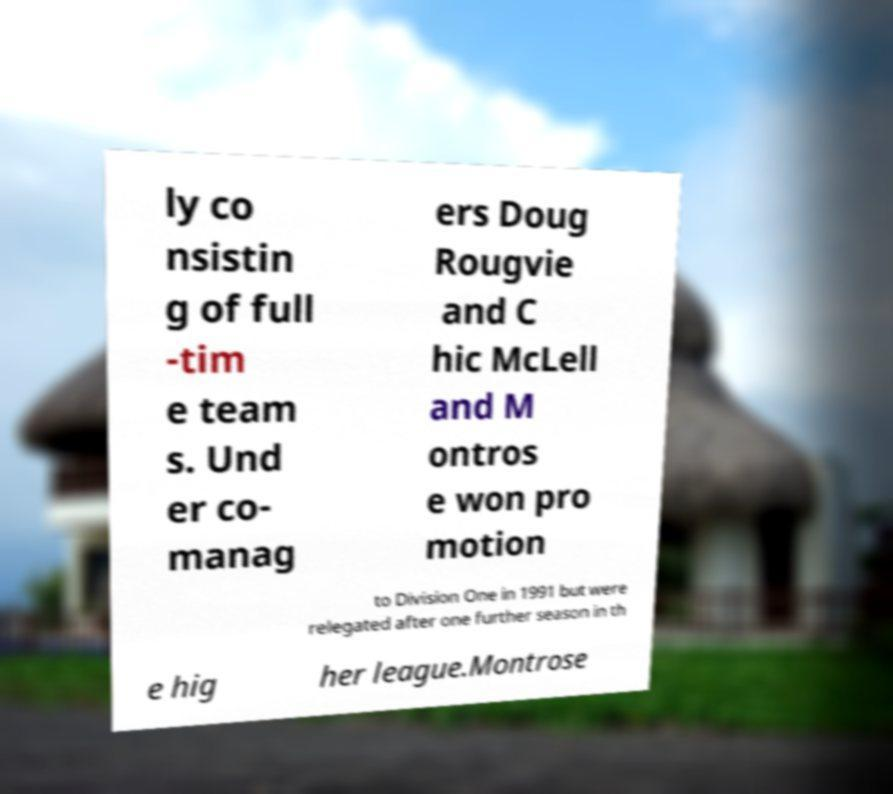There's text embedded in this image that I need extracted. Can you transcribe it verbatim? ly co nsistin g of full -tim e team s. Und er co- manag ers Doug Rougvie and C hic McLell and M ontros e won pro motion to Division One in 1991 but were relegated after one further season in th e hig her league.Montrose 